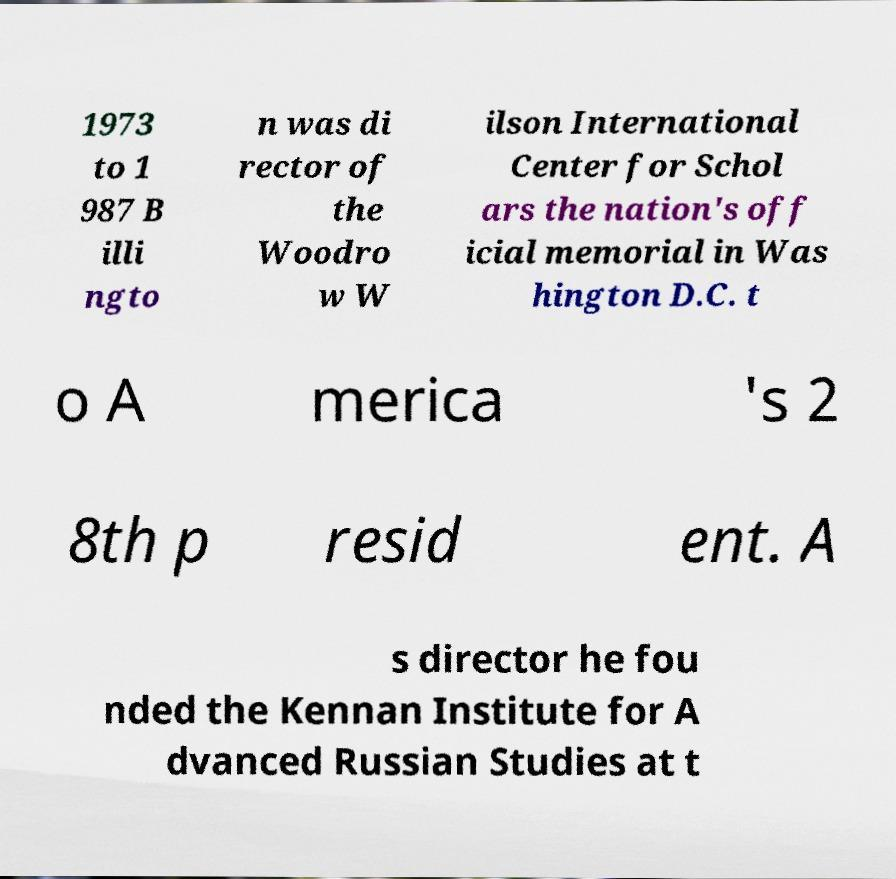Can you accurately transcribe the text from the provided image for me? 1973 to 1 987 B illi ngto n was di rector of the Woodro w W ilson International Center for Schol ars the nation's off icial memorial in Was hington D.C. t o A merica 's 2 8th p resid ent. A s director he fou nded the Kennan Institute for A dvanced Russian Studies at t 